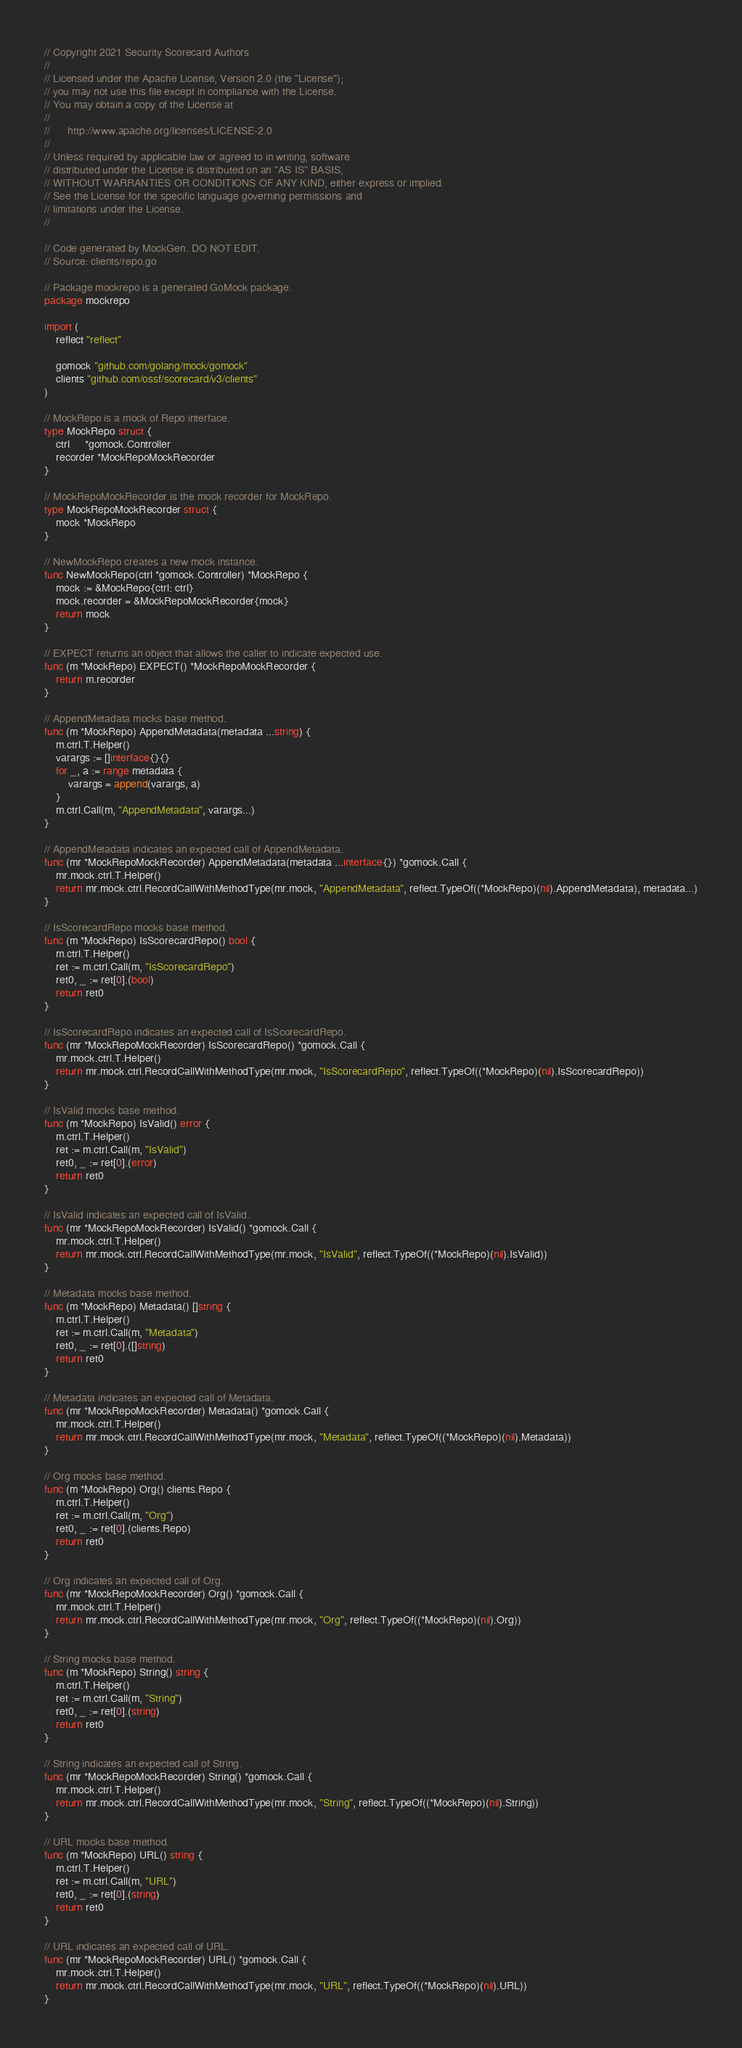Convert code to text. <code><loc_0><loc_0><loc_500><loc_500><_Go_>// Copyright 2021 Security Scorecard Authors
//
// Licensed under the Apache License, Version 2.0 (the "License");
// you may not use this file except in compliance with the License.
// You may obtain a copy of the License at
//
//      http://www.apache.org/licenses/LICENSE-2.0
//
// Unless required by applicable law or agreed to in writing, software
// distributed under the License is distributed on an "AS IS" BASIS,
// WITHOUT WARRANTIES OR CONDITIONS OF ANY KIND, either express or implied.
// See the License for the specific language governing permissions and
// limitations under the License.
//

// Code generated by MockGen. DO NOT EDIT.
// Source: clients/repo.go

// Package mockrepo is a generated GoMock package.
package mockrepo

import (
	reflect "reflect"

	gomock "github.com/golang/mock/gomock"
	clients "github.com/ossf/scorecard/v3/clients"
)

// MockRepo is a mock of Repo interface.
type MockRepo struct {
	ctrl     *gomock.Controller
	recorder *MockRepoMockRecorder
}

// MockRepoMockRecorder is the mock recorder for MockRepo.
type MockRepoMockRecorder struct {
	mock *MockRepo
}

// NewMockRepo creates a new mock instance.
func NewMockRepo(ctrl *gomock.Controller) *MockRepo {
	mock := &MockRepo{ctrl: ctrl}
	mock.recorder = &MockRepoMockRecorder{mock}
	return mock
}

// EXPECT returns an object that allows the caller to indicate expected use.
func (m *MockRepo) EXPECT() *MockRepoMockRecorder {
	return m.recorder
}

// AppendMetadata mocks base method.
func (m *MockRepo) AppendMetadata(metadata ...string) {
	m.ctrl.T.Helper()
	varargs := []interface{}{}
	for _, a := range metadata {
		varargs = append(varargs, a)
	}
	m.ctrl.Call(m, "AppendMetadata", varargs...)
}

// AppendMetadata indicates an expected call of AppendMetadata.
func (mr *MockRepoMockRecorder) AppendMetadata(metadata ...interface{}) *gomock.Call {
	mr.mock.ctrl.T.Helper()
	return mr.mock.ctrl.RecordCallWithMethodType(mr.mock, "AppendMetadata", reflect.TypeOf((*MockRepo)(nil).AppendMetadata), metadata...)
}

// IsScorecardRepo mocks base method.
func (m *MockRepo) IsScorecardRepo() bool {
	m.ctrl.T.Helper()
	ret := m.ctrl.Call(m, "IsScorecardRepo")
	ret0, _ := ret[0].(bool)
	return ret0
}

// IsScorecardRepo indicates an expected call of IsScorecardRepo.
func (mr *MockRepoMockRecorder) IsScorecardRepo() *gomock.Call {
	mr.mock.ctrl.T.Helper()
	return mr.mock.ctrl.RecordCallWithMethodType(mr.mock, "IsScorecardRepo", reflect.TypeOf((*MockRepo)(nil).IsScorecardRepo))
}

// IsValid mocks base method.
func (m *MockRepo) IsValid() error {
	m.ctrl.T.Helper()
	ret := m.ctrl.Call(m, "IsValid")
	ret0, _ := ret[0].(error)
	return ret0
}

// IsValid indicates an expected call of IsValid.
func (mr *MockRepoMockRecorder) IsValid() *gomock.Call {
	mr.mock.ctrl.T.Helper()
	return mr.mock.ctrl.RecordCallWithMethodType(mr.mock, "IsValid", reflect.TypeOf((*MockRepo)(nil).IsValid))
}

// Metadata mocks base method.
func (m *MockRepo) Metadata() []string {
	m.ctrl.T.Helper()
	ret := m.ctrl.Call(m, "Metadata")
	ret0, _ := ret[0].([]string)
	return ret0
}

// Metadata indicates an expected call of Metadata.
func (mr *MockRepoMockRecorder) Metadata() *gomock.Call {
	mr.mock.ctrl.T.Helper()
	return mr.mock.ctrl.RecordCallWithMethodType(mr.mock, "Metadata", reflect.TypeOf((*MockRepo)(nil).Metadata))
}

// Org mocks base method.
func (m *MockRepo) Org() clients.Repo {
	m.ctrl.T.Helper()
	ret := m.ctrl.Call(m, "Org")
	ret0, _ := ret[0].(clients.Repo)
	return ret0
}

// Org indicates an expected call of Org.
func (mr *MockRepoMockRecorder) Org() *gomock.Call {
	mr.mock.ctrl.T.Helper()
	return mr.mock.ctrl.RecordCallWithMethodType(mr.mock, "Org", reflect.TypeOf((*MockRepo)(nil).Org))
}

// String mocks base method.
func (m *MockRepo) String() string {
	m.ctrl.T.Helper()
	ret := m.ctrl.Call(m, "String")
	ret0, _ := ret[0].(string)
	return ret0
}

// String indicates an expected call of String.
func (mr *MockRepoMockRecorder) String() *gomock.Call {
	mr.mock.ctrl.T.Helper()
	return mr.mock.ctrl.RecordCallWithMethodType(mr.mock, "String", reflect.TypeOf((*MockRepo)(nil).String))
}

// URL mocks base method.
func (m *MockRepo) URL() string {
	m.ctrl.T.Helper()
	ret := m.ctrl.Call(m, "URL")
	ret0, _ := ret[0].(string)
	return ret0
}

// URL indicates an expected call of URL.
func (mr *MockRepoMockRecorder) URL() *gomock.Call {
	mr.mock.ctrl.T.Helper()
	return mr.mock.ctrl.RecordCallWithMethodType(mr.mock, "URL", reflect.TypeOf((*MockRepo)(nil).URL))
}
</code> 